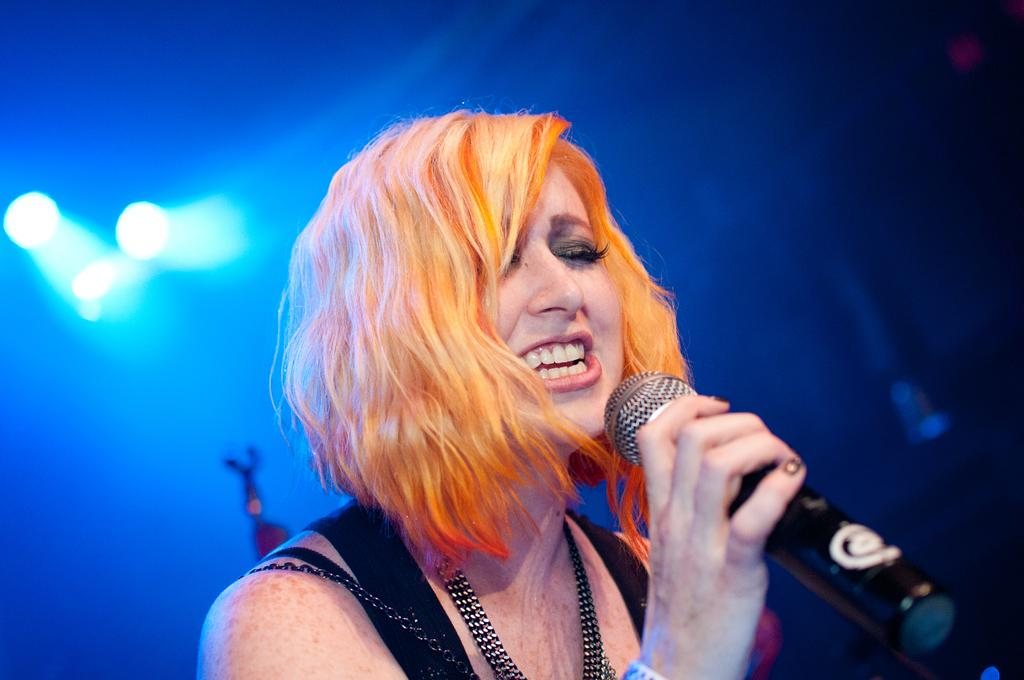Who is the main subject in the image? There is a woman in the image. What is the woman holding in the image? The woman is holding a microphone (Mic) in the image. Where is the microphone located in the image? The microphone is visible in the bottom of the image. What type of animals can be seen at the zoo in the image? There is no zoo or animals present in the image; it features a woman holding a microphone. How many nails are visible in the image? There are no nails visible in the image. 